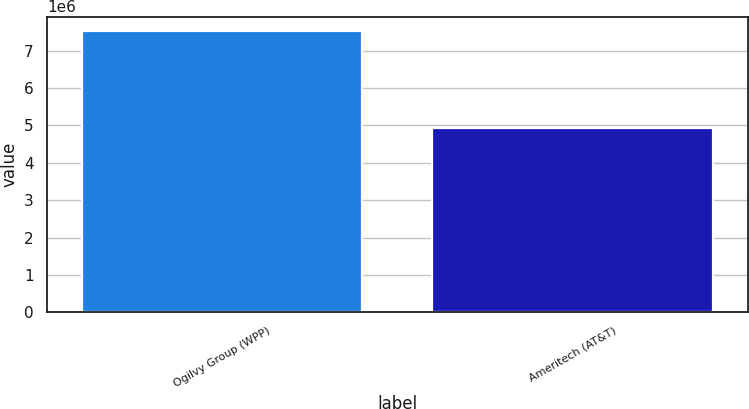Convert chart. <chart><loc_0><loc_0><loc_500><loc_500><bar_chart><fcel>Ogilvy Group (WPP)<fcel>Ameritech (AT&T)<nl><fcel>7.537e+06<fcel>4.924e+06<nl></chart> 